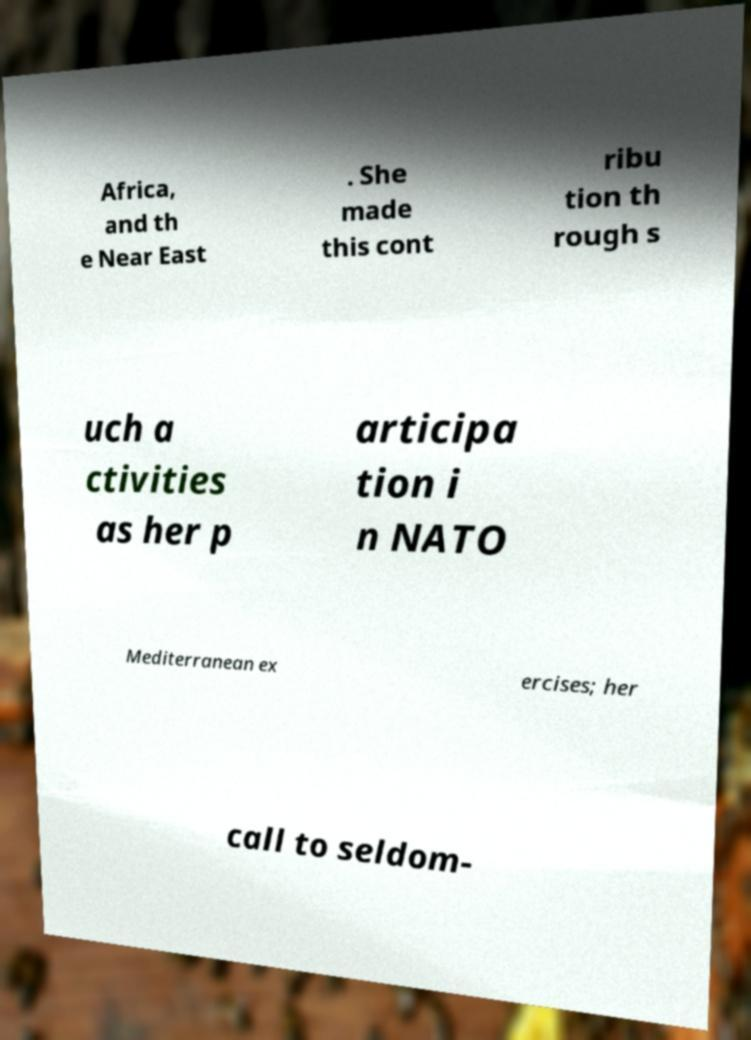There's text embedded in this image that I need extracted. Can you transcribe it verbatim? Africa, and th e Near East . She made this cont ribu tion th rough s uch a ctivities as her p articipa tion i n NATO Mediterranean ex ercises; her call to seldom- 